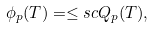<formula> <loc_0><loc_0><loc_500><loc_500>\phi _ { p } ( T ) = \leq s c Q _ { p } ( T ) ,</formula> 